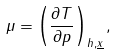Convert formula to latex. <formula><loc_0><loc_0><loc_500><loc_500>\mu = \left ( \frac { \partial T } { \partial p } \right ) _ { h , { \underline { x } } } ,</formula> 